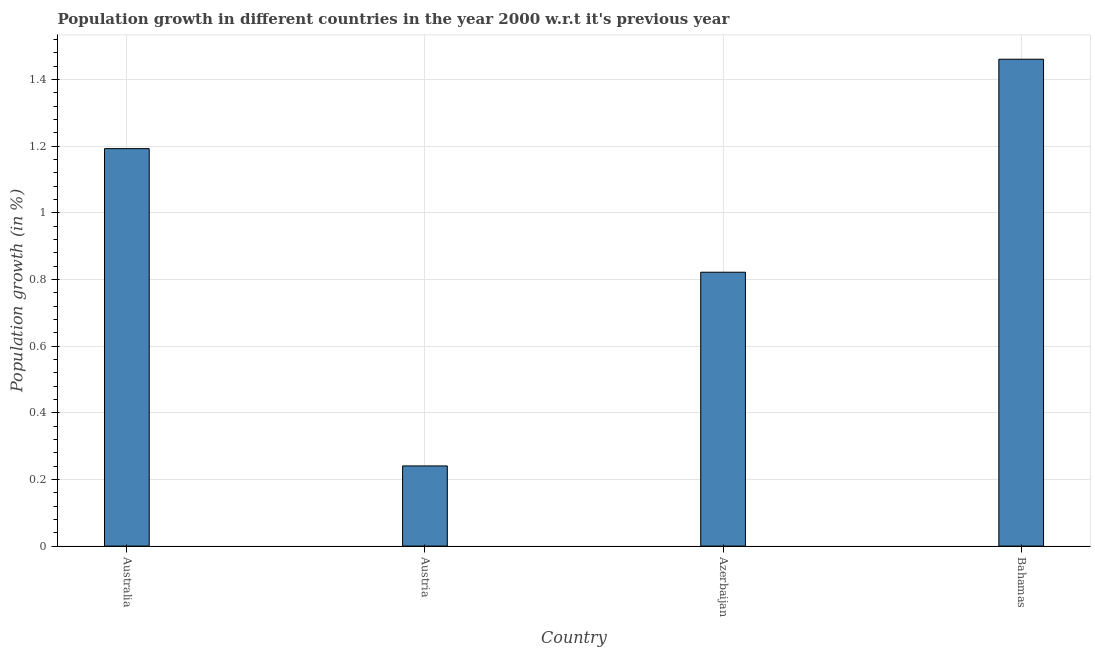Does the graph contain any zero values?
Your response must be concise. No. What is the title of the graph?
Your answer should be compact. Population growth in different countries in the year 2000 w.r.t it's previous year. What is the label or title of the Y-axis?
Give a very brief answer. Population growth (in %). What is the population growth in Bahamas?
Ensure brevity in your answer.  1.46. Across all countries, what is the maximum population growth?
Keep it short and to the point. 1.46. Across all countries, what is the minimum population growth?
Keep it short and to the point. 0.24. In which country was the population growth maximum?
Offer a very short reply. Bahamas. In which country was the population growth minimum?
Provide a short and direct response. Austria. What is the sum of the population growth?
Make the answer very short. 3.71. What is the difference between the population growth in Azerbaijan and Bahamas?
Offer a very short reply. -0.64. What is the average population growth per country?
Offer a terse response. 0.93. What is the median population growth?
Offer a very short reply. 1.01. In how many countries, is the population growth greater than 1.32 %?
Your answer should be compact. 1. What is the ratio of the population growth in Australia to that in Austria?
Provide a short and direct response. 4.96. What is the difference between the highest and the second highest population growth?
Your answer should be compact. 0.27. Is the sum of the population growth in Austria and Azerbaijan greater than the maximum population growth across all countries?
Provide a short and direct response. No. What is the difference between the highest and the lowest population growth?
Offer a very short reply. 1.22. In how many countries, is the population growth greater than the average population growth taken over all countries?
Your answer should be very brief. 2. Are all the bars in the graph horizontal?
Provide a succinct answer. No. Are the values on the major ticks of Y-axis written in scientific E-notation?
Give a very brief answer. No. What is the Population growth (in %) of Australia?
Your response must be concise. 1.19. What is the Population growth (in %) in Austria?
Your answer should be compact. 0.24. What is the Population growth (in %) in Azerbaijan?
Your response must be concise. 0.82. What is the Population growth (in %) of Bahamas?
Your response must be concise. 1.46. What is the difference between the Population growth (in %) in Australia and Austria?
Your answer should be very brief. 0.95. What is the difference between the Population growth (in %) in Australia and Azerbaijan?
Provide a succinct answer. 0.37. What is the difference between the Population growth (in %) in Australia and Bahamas?
Give a very brief answer. -0.27. What is the difference between the Population growth (in %) in Austria and Azerbaijan?
Offer a very short reply. -0.58. What is the difference between the Population growth (in %) in Austria and Bahamas?
Keep it short and to the point. -1.22. What is the difference between the Population growth (in %) in Azerbaijan and Bahamas?
Keep it short and to the point. -0.64. What is the ratio of the Population growth (in %) in Australia to that in Austria?
Make the answer very short. 4.96. What is the ratio of the Population growth (in %) in Australia to that in Azerbaijan?
Ensure brevity in your answer.  1.45. What is the ratio of the Population growth (in %) in Australia to that in Bahamas?
Make the answer very short. 0.82. What is the ratio of the Population growth (in %) in Austria to that in Azerbaijan?
Give a very brief answer. 0.29. What is the ratio of the Population growth (in %) in Austria to that in Bahamas?
Keep it short and to the point. 0.17. What is the ratio of the Population growth (in %) in Azerbaijan to that in Bahamas?
Offer a very short reply. 0.56. 